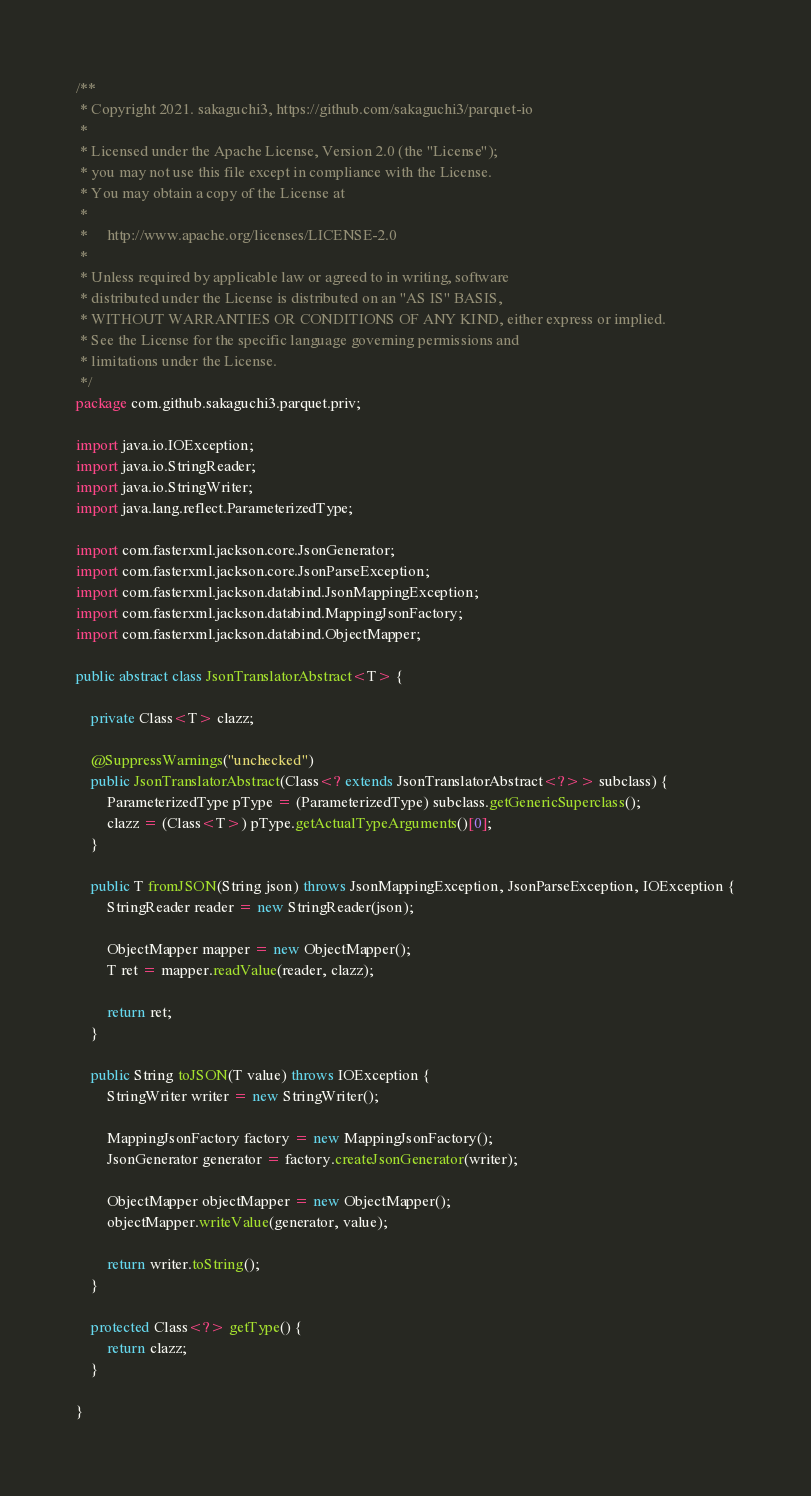<code> <loc_0><loc_0><loc_500><loc_500><_Java_>/**
 * Copyright 2021. sakaguchi3, https://github.com/sakaguchi3/parquet-io
 * 
 * Licensed under the Apache License, Version 2.0 (the "License");
 * you may not use this file except in compliance with the License.
 * You may obtain a copy of the License at
 * 
 *     http://www.apache.org/licenses/LICENSE-2.0
 * 
 * Unless required by applicable law or agreed to in writing, software
 * distributed under the License is distributed on an "AS IS" BASIS,
 * WITHOUT WARRANTIES OR CONDITIONS OF ANY KIND, either express or implied.
 * See the License for the specific language governing permissions and
 * limitations under the License.
 */
package com.github.sakaguchi3.parquet.priv;

import java.io.IOException;
import java.io.StringReader;
import java.io.StringWriter;
import java.lang.reflect.ParameterizedType;

import com.fasterxml.jackson.core.JsonGenerator;
import com.fasterxml.jackson.core.JsonParseException;
import com.fasterxml.jackson.databind.JsonMappingException;
import com.fasterxml.jackson.databind.MappingJsonFactory;
import com.fasterxml.jackson.databind.ObjectMapper;

public abstract class JsonTranslatorAbstract<T> {

	private Class<T> clazz;

	@SuppressWarnings("unchecked")
	public JsonTranslatorAbstract(Class<? extends JsonTranslatorAbstract<?>> subclass) {
		ParameterizedType pType = (ParameterizedType) subclass.getGenericSuperclass();
		clazz = (Class<T>) pType.getActualTypeArguments()[0];
	}

	public T fromJSON(String json) throws JsonMappingException, JsonParseException, IOException {
		StringReader reader = new StringReader(json);

		ObjectMapper mapper = new ObjectMapper();
		T ret = mapper.readValue(reader, clazz);

		return ret;
	}

	public String toJSON(T value) throws IOException {
		StringWriter writer = new StringWriter();

		MappingJsonFactory factory = new MappingJsonFactory();
		JsonGenerator generator = factory.createJsonGenerator(writer);

		ObjectMapper objectMapper = new ObjectMapper();
		objectMapper.writeValue(generator, value);

		return writer.toString();
	}

	protected Class<?> getType() {
		return clazz;
	}

}
</code> 